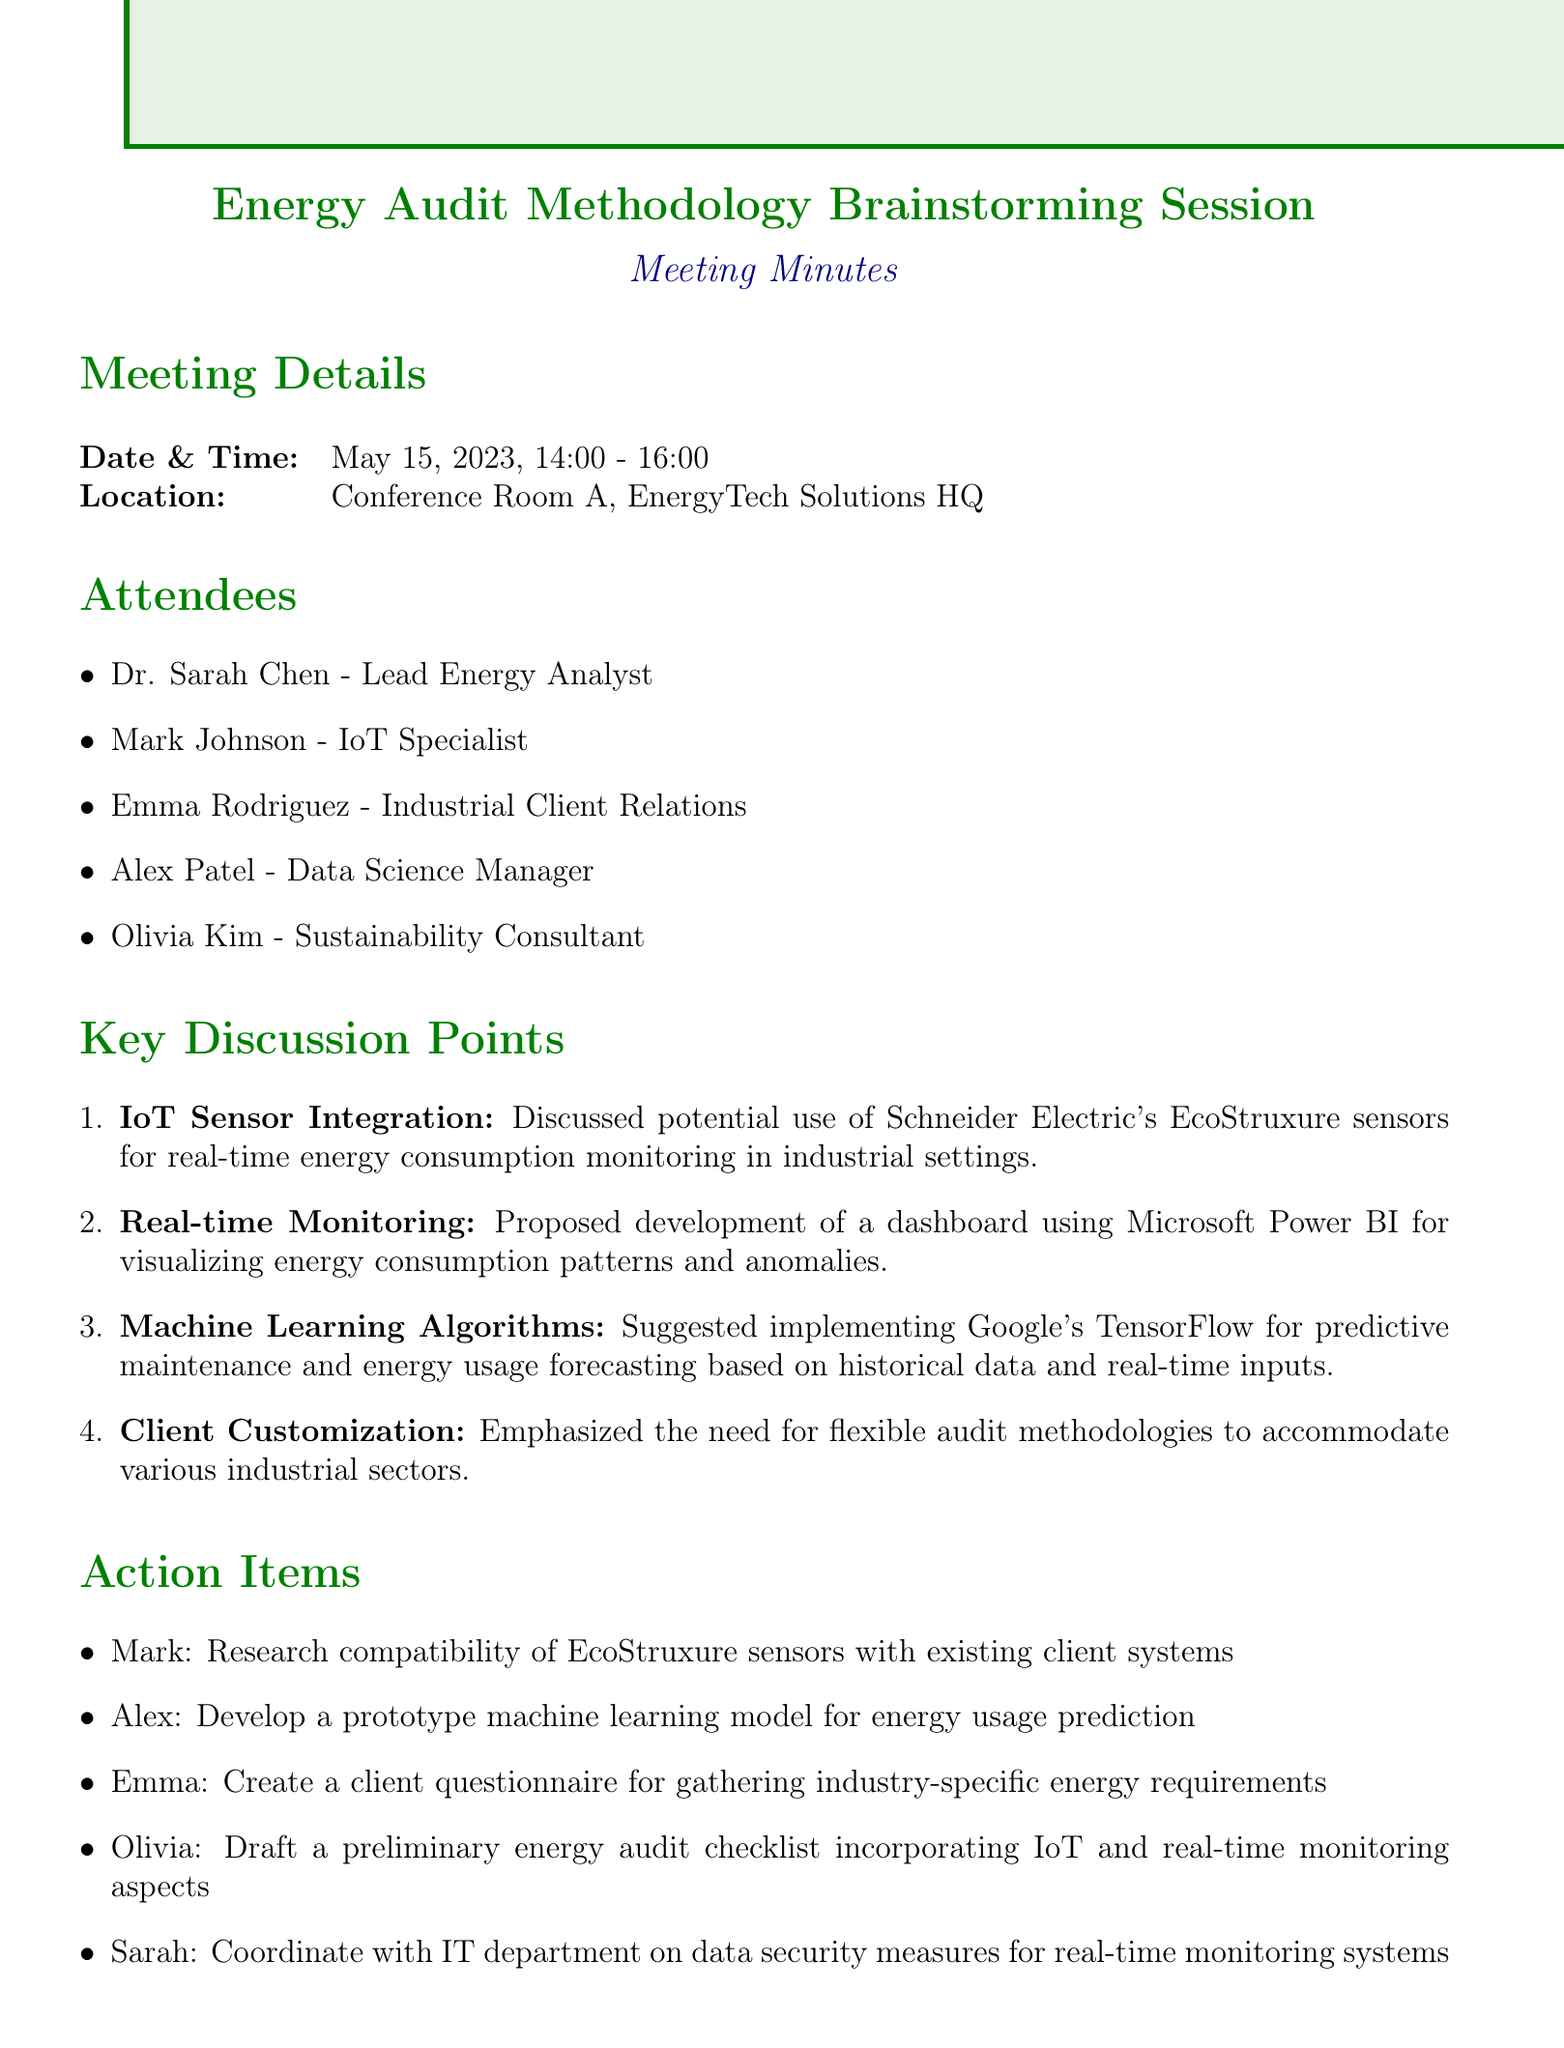what is the date of the meeting? The date of the meeting is specified in the meeting details section.
Answer: May 15, 2023 who attended the meeting as the Data Science Manager? This information can be found in the attendees section of the document.
Answer: Alex Patel what is one proposed tool for visualizing energy consumption patterns? The discussion point mentions a specific dashboard tool for this purpose.
Answer: Microsoft Power BI what is the follow-up meeting date? The next steps section outlines the date for the follow-up meeting.
Answer: May 29, 2023 what was discussed regarding IoT sensors? This question requires synthesizing information from the key discussion points section.
Answer: Schneider Electric's EcoStruxure sensors how many attendees were there? This question can be answered by counting the names listed in the attendees section.
Answer: Five which action item involves creating a client questionnaire? This action item specifies who is responsible for this task, which can be found in the action items section.
Answer: Emma what is one machine learning technology discussed for the energy audit? The key discussion points detail a specific technology for predictive analysis.
Answer: Google's TensorFlow 